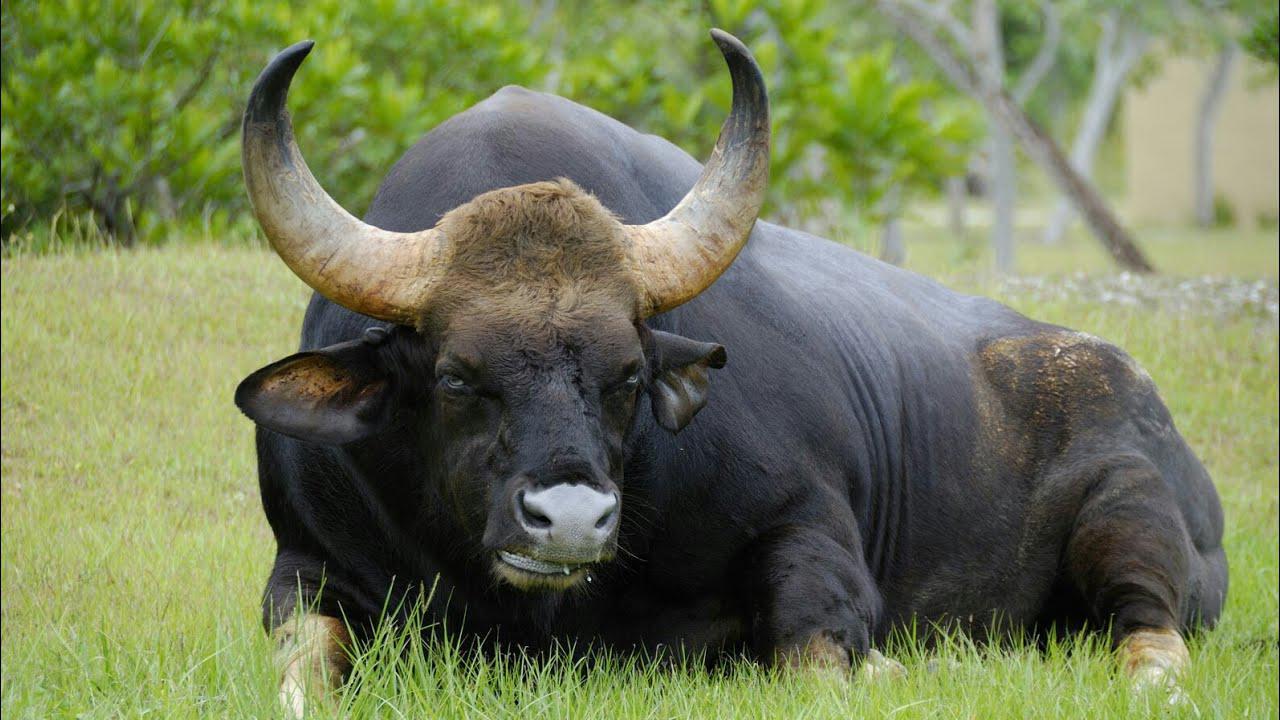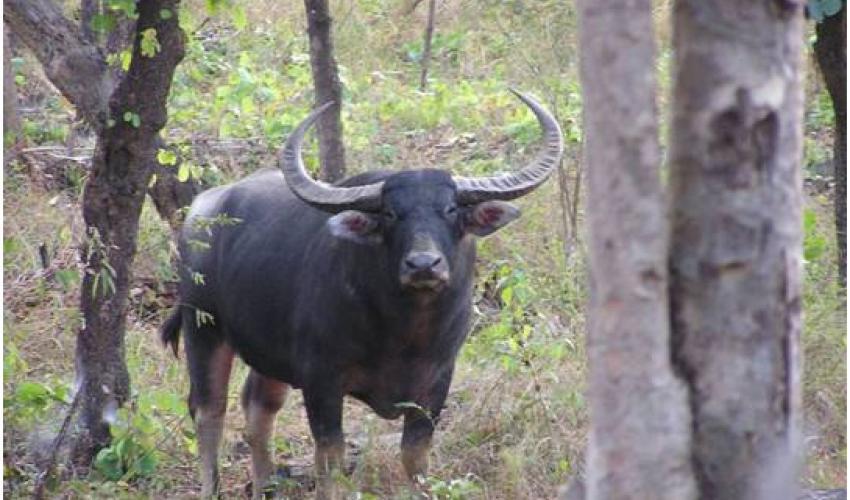The first image is the image on the left, the second image is the image on the right. Examine the images to the left and right. Is the description "Right image contains at least twice as many horned animals as the left image." accurate? Answer yes or no. No. 